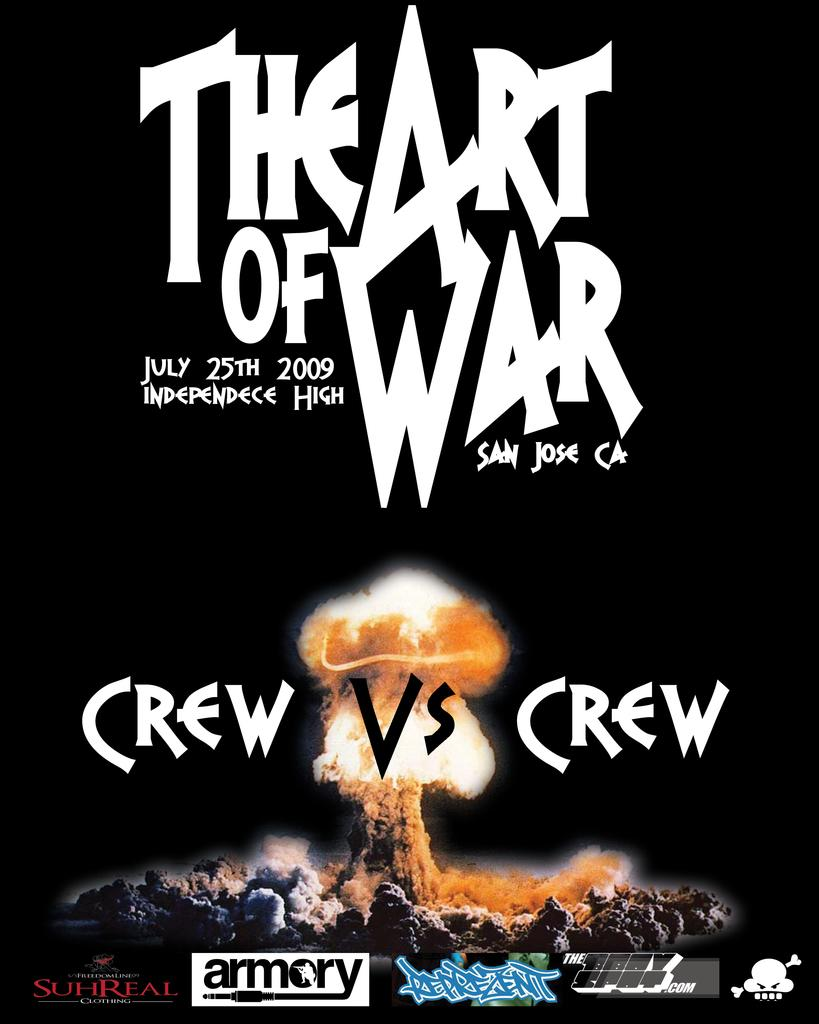Provide a one-sentence caption for the provided image. Poster for Crew vs Crew which takes place in San Jose. 